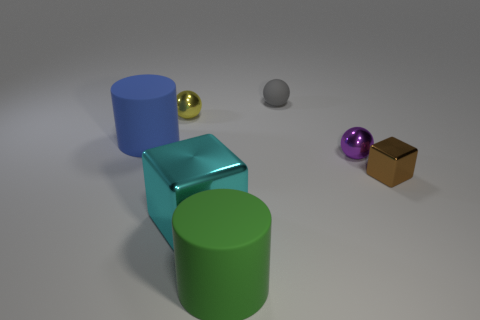The other thing that is the same shape as the big cyan thing is what size?
Offer a terse response. Small. What number of things are rubber objects in front of the brown metal object or matte cylinders in front of the brown shiny block?
Provide a succinct answer. 1. There is a matte thing that is in front of the large rubber cylinder behind the green object; what is its shape?
Your answer should be compact. Cylinder. Is there any other thing that is the same color as the tiny shiny block?
Offer a terse response. No. Is there anything else that is the same size as the cyan metal cube?
Offer a very short reply. Yes. What number of objects are tiny objects or cylinders?
Give a very brief answer. 6. Are there any yellow metallic things that have the same size as the yellow ball?
Provide a short and direct response. No. The tiny yellow thing has what shape?
Offer a terse response. Sphere. Are there more small purple things left of the cyan thing than cyan objects that are on the left side of the brown shiny object?
Ensure brevity in your answer.  No. There is a big object that is to the left of the yellow metal object; does it have the same color as the small metallic sphere in front of the blue object?
Your answer should be compact. No. 